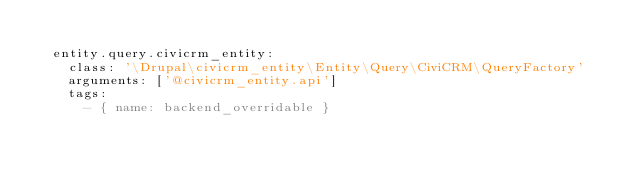Convert code to text. <code><loc_0><loc_0><loc_500><loc_500><_YAML_>
  entity.query.civicrm_entity:
    class: '\Drupal\civicrm_entity\Entity\Query\CiviCRM\QueryFactory'
    arguments: ['@civicrm_entity.api']
    tags:
      - { name: backend_overridable }
</code> 